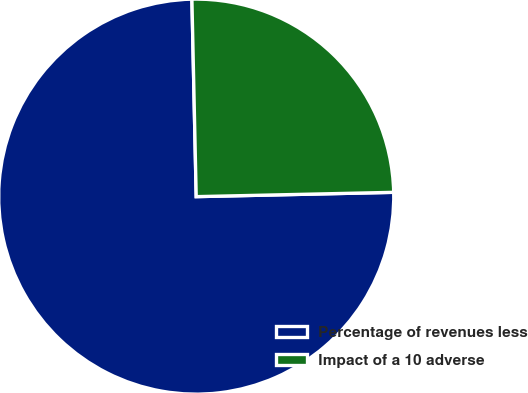<chart> <loc_0><loc_0><loc_500><loc_500><pie_chart><fcel>Percentage of revenues less<fcel>Impact of a 10 adverse<nl><fcel>75.0%<fcel>25.0%<nl></chart> 